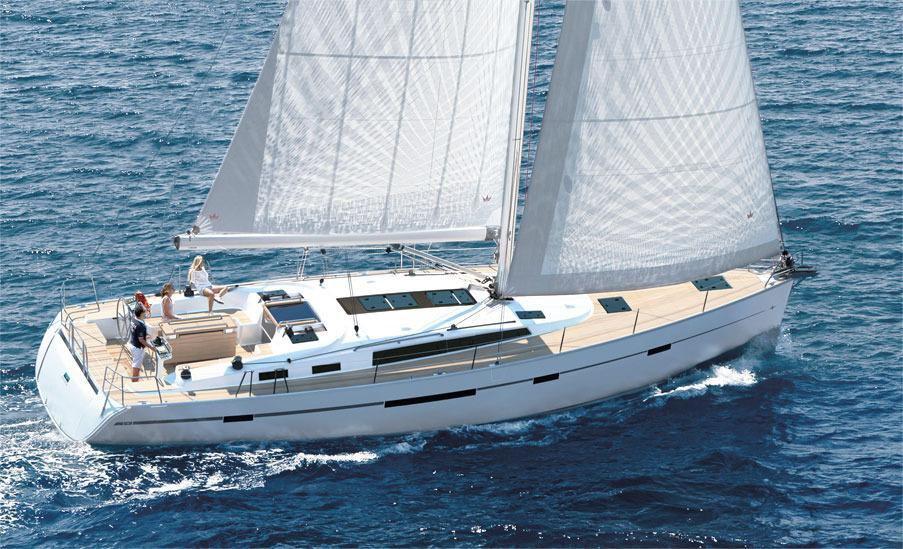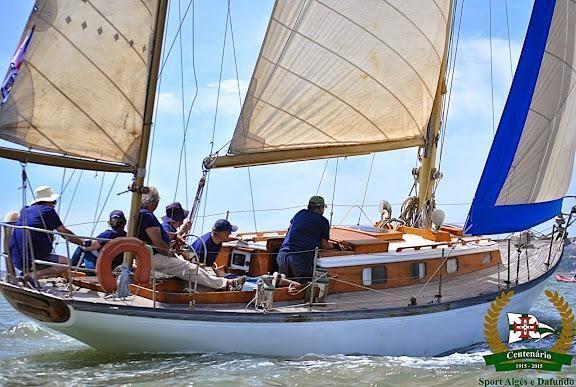The first image is the image on the left, the second image is the image on the right. Considering the images on both sides, is "Hilly land is visible behind one of the boats." valid? Answer yes or no. No. 